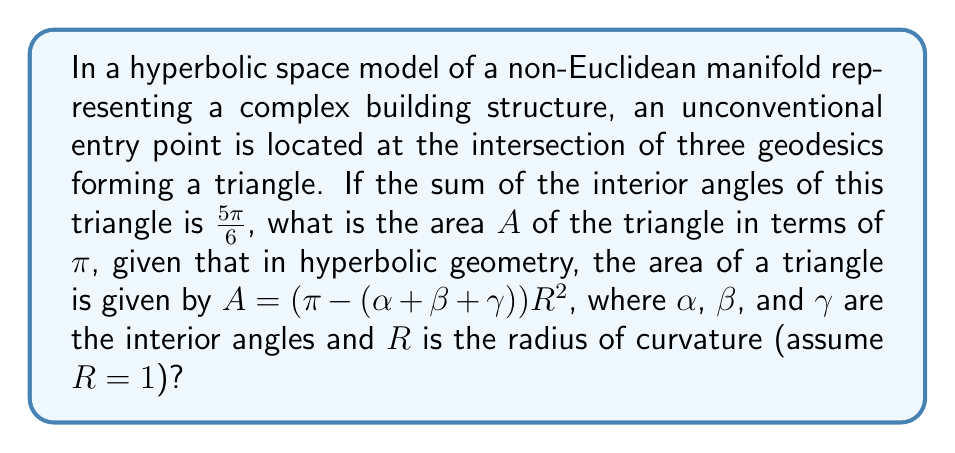Solve this math problem. Let's approach this step-by-step:

1) In hyperbolic geometry, the sum of the interior angles of a triangle is always less than $\pi$. This property is crucial for identifying unconventional entry points in non-Euclidean spaces.

2) We are given that the sum of the interior angles is $\frac{5\pi}{6}$. Let's call this sum $S$:

   $S = \alpha + \beta + \gamma = \frac{5\pi}{6}$

3) The formula for the area of a hyperbolic triangle is:

   $A = (\pi - (\alpha + \beta + \gamma))R^2$

4) We're told to assume $R=1$, so our formula simplifies to:

   $A = \pi - (\alpha + \beta + \gamma)$

5) We can substitute our known value for $(\alpha + \beta + \gamma)$:

   $A = \pi - \frac{5\pi}{6}$

6) Now we can simplify:

   $A = \pi - \frac{5\pi}{6} = \frac{6\pi}{6} - \frac{5\pi}{6} = \frac{\pi}{6}$

Therefore, the area of the triangle is $\frac{\pi}{6}$.
Answer: $\frac{\pi}{6}$ 